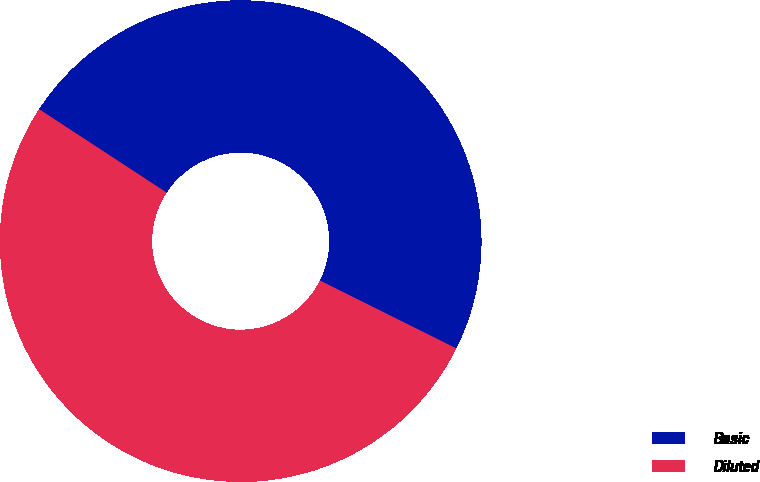Convert chart to OTSL. <chart><loc_0><loc_0><loc_500><loc_500><pie_chart><fcel>Basic<fcel>Diluted<nl><fcel>48.13%<fcel>51.87%<nl></chart> 